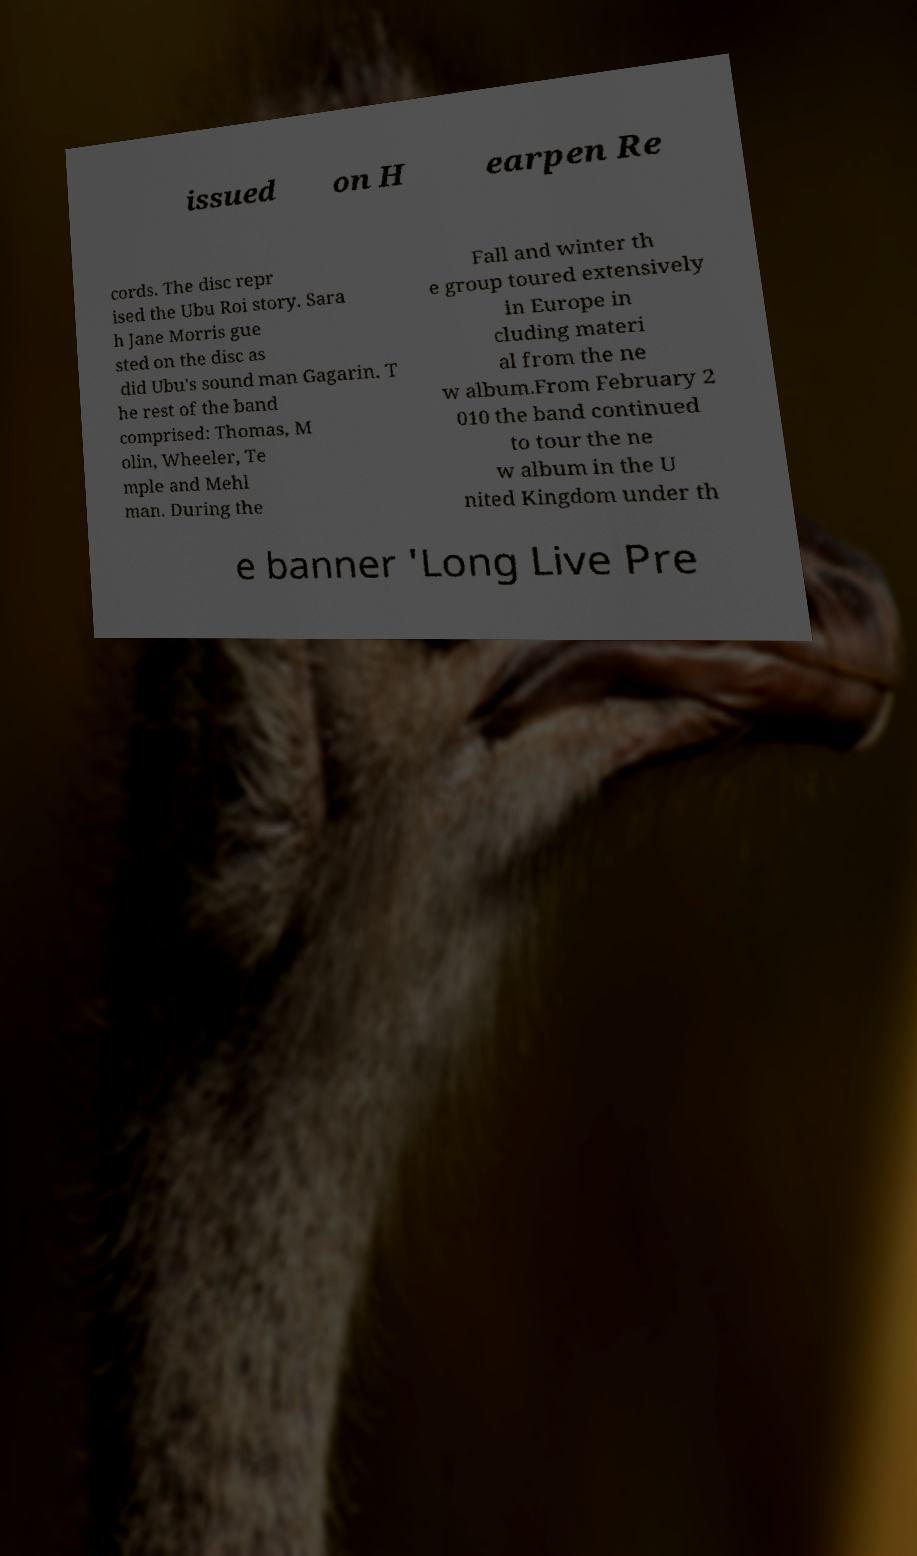What messages or text are displayed in this image? I need them in a readable, typed format. issued on H earpen Re cords. The disc repr ised the Ubu Roi story. Sara h Jane Morris gue sted on the disc as did Ubu's sound man Gagarin. T he rest of the band comprised: Thomas, M olin, Wheeler, Te mple and Mehl man. During the Fall and winter th e group toured extensively in Europe in cluding materi al from the ne w album.From February 2 010 the band continued to tour the ne w album in the U nited Kingdom under th e banner 'Long Live Pre 